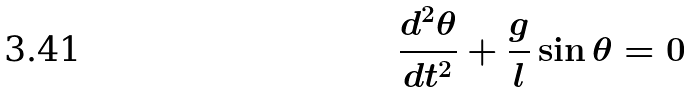<formula> <loc_0><loc_0><loc_500><loc_500>\frac { d ^ { 2 } \theta } { d t ^ { 2 } } + \frac { g } { l } \sin \theta = 0</formula> 